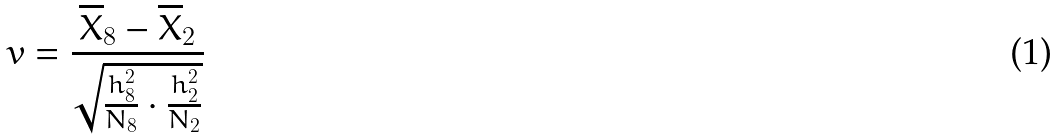Convert formula to latex. <formula><loc_0><loc_0><loc_500><loc_500>v = \frac { \overline { X } _ { 8 } - \overline { X } _ { 2 } } { \sqrt { \frac { h _ { 8 } ^ { 2 } } { N _ { 8 } } \cdot \frac { h _ { 2 } ^ { 2 } } { N _ { 2 } } } }</formula> 